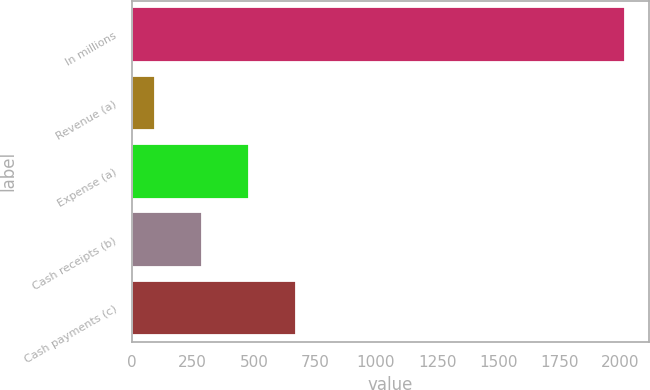Convert chart. <chart><loc_0><loc_0><loc_500><loc_500><bar_chart><fcel>In millions<fcel>Revenue (a)<fcel>Expense (a)<fcel>Cash receipts (b)<fcel>Cash payments (c)<nl><fcel>2018<fcel>95<fcel>479.6<fcel>287.3<fcel>671.9<nl></chart> 